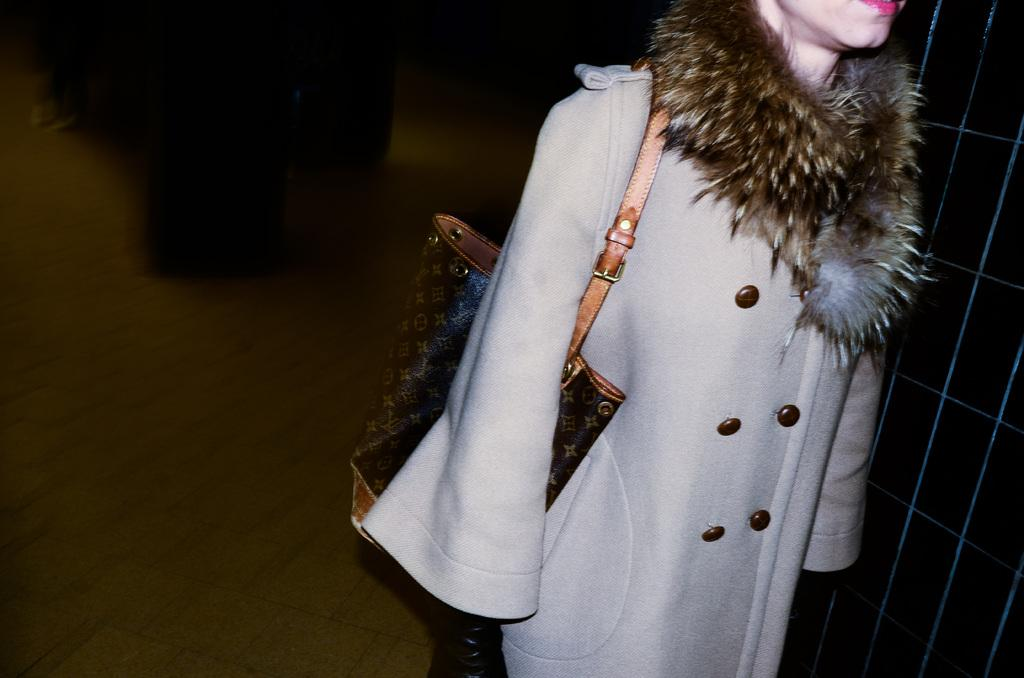Who is the main subject in the image? There is a woman in the image. What is the woman doing in the image? The woman is standing over a place. What is the woman wearing in the image? The woman is wearing a fur coat. What accessory is the woman carrying in the image? The woman is carrying a handbag. What architectural feature is present beside the woman in the image? There is a gate present beside the woman. What type of body language is the woman displaying in the image? The image does not provide enough information to determine the woman's body language. What sign is visible on the gate beside the woman? There is no sign visible on the gate beside the woman in the image. 